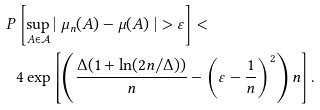Convert formula to latex. <formula><loc_0><loc_0><loc_500><loc_500>P & \left [ \sup _ { A \in \mathcal { A } } | \ \mu _ { n } ( A ) - \mu ( A ) \ | > \varepsilon \right ] < \\ & 4 \exp \left [ \left ( \frac { \Delta ( 1 + \ln ( 2 n / \Delta ) ) } { n } - \left ( \varepsilon - \frac { 1 } { n } \right ) ^ { 2 } \right ) n \right ] . \\</formula> 